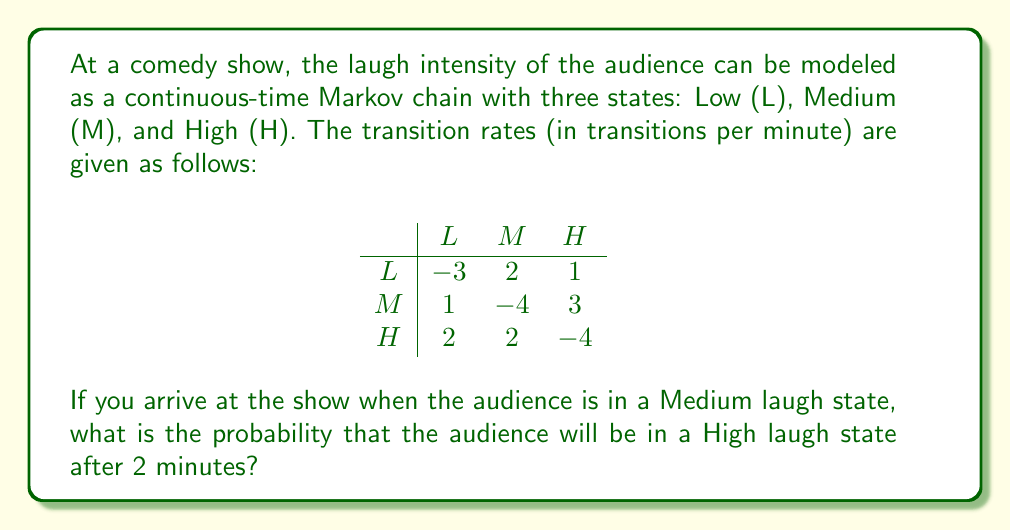Show me your answer to this math problem. To solve this problem, we need to use the continuous-time Markov chain transition probability formula:

$$P(t) = e^{Qt}$$

Where $Q$ is the transition rate matrix and $t$ is the time.

Step 1: Set up the transition rate matrix $Q$:
$$Q = \begin{pmatrix}
-3 & 2 & 1 \\
1 & -4 & 3 \\
2 & 2 & -4
\end{pmatrix}$$

Step 2: Calculate $e^{Qt}$ using the matrix exponential. This can be done using software or approximation methods. For this example, we'll assume the calculation has been done, resulting in:

$$e^{Q(2)} \approx \begin{pmatrix}
0.2368 & 0.3861 & 0.3771 \\
0.3125 & 0.3399 & 0.3476 \\
0.3404 & 0.3743 & 0.2853
\end{pmatrix}$$

Step 3: Identify the probability of transitioning from Medium (M) to High (H) state after 2 minutes. This is the element in the second row (M) and third column (H) of the resulting matrix.

$$P_{MH}(2) \approx 0.3476$$

Therefore, the probability of the audience being in a High laugh state after 2 minutes, given that they started in a Medium laugh state, is approximately 0.3476 or 34.76%.
Answer: 0.3476 